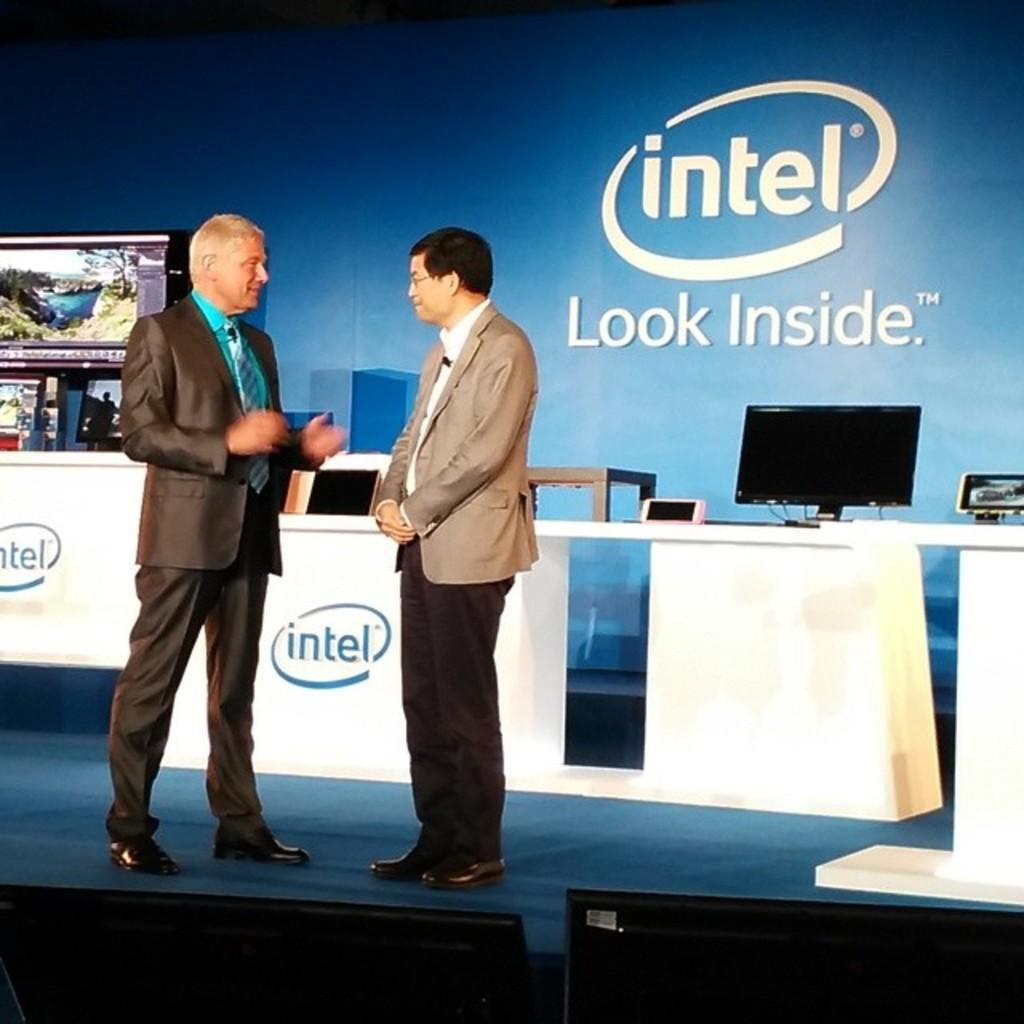How many men are in the image? There are two men in the image. What are the men wearing on their upper bodies? Both men are wearing blazers. What type of footwear are the men wearing? Both men are wearing shoes. Where are the men standing in the image? The men are standing on a platform. What electronic device is present in the image? There is a monitor in the image. What can be seen in the background of the image? There is a banner in the background of the image. What type of food is the beginner zebra eating in the image? There is no zebra or food present in the image. 